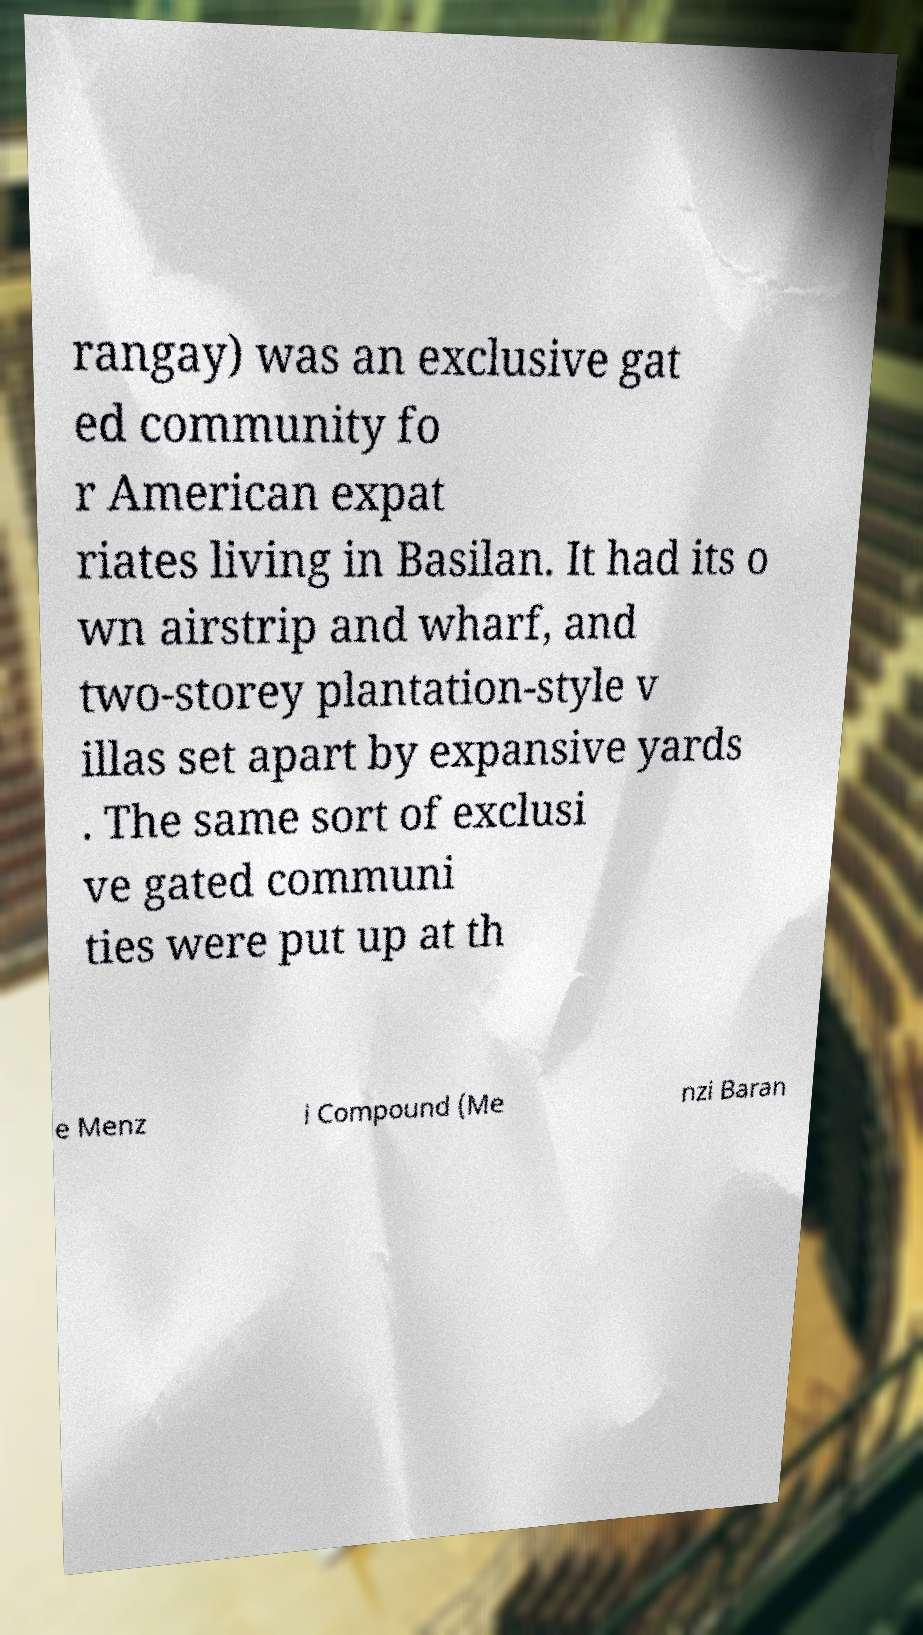For documentation purposes, I need the text within this image transcribed. Could you provide that? rangay) was an exclusive gat ed community fo r American expat riates living in Basilan. It had its o wn airstrip and wharf, and two-storey plantation-style v illas set apart by expansive yards . The same sort of exclusi ve gated communi ties were put up at th e Menz i Compound (Me nzi Baran 